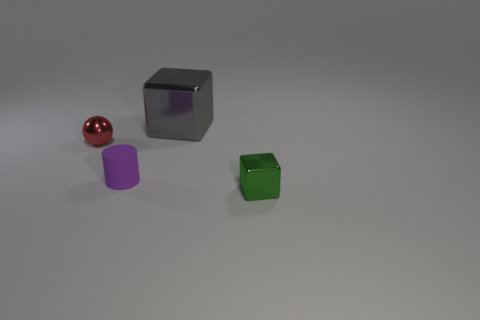Are there any other things that are the same size as the gray shiny cube?
Offer a very short reply. No. There is another large object that is the same shape as the green object; what is its color?
Keep it short and to the point. Gray. The other block that is the same material as the gray cube is what color?
Give a very brief answer. Green. What is the color of the shiny object that is in front of the small shiny thing left of the metal block behind the tiny purple rubber cylinder?
Provide a succinct answer. Green. How many rubber objects are either red cylinders or red balls?
Your answer should be very brief. 0. Is the number of tiny metallic balls right of the green metallic thing greater than the number of gray metal cubes in front of the small purple cylinder?
Provide a succinct answer. No. How many other objects are the same size as the gray thing?
Make the answer very short. 0. There is a block on the left side of the tiny metal thing that is right of the gray metal thing; how big is it?
Your answer should be compact. Large. What number of tiny objects are red spheres or yellow cubes?
Ensure brevity in your answer.  1. There is a metallic block that is left of the tiny green cube to the right of the block on the left side of the green metal cube; what size is it?
Your answer should be very brief. Large. 